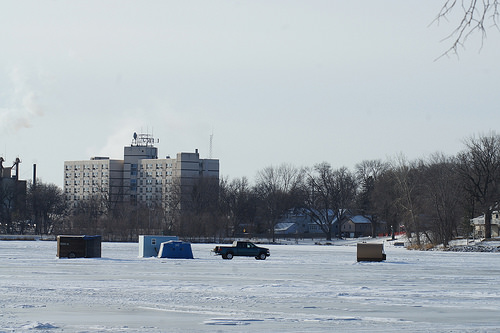<image>
Is there a truck on the ice? Yes. Looking at the image, I can see the truck is positioned on top of the ice, with the ice providing support. 